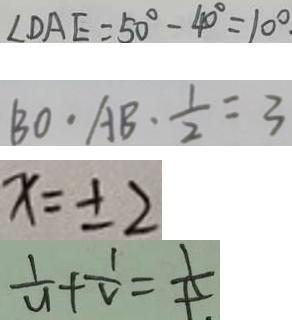<formula> <loc_0><loc_0><loc_500><loc_500>\angle D A E = 5 0 ^ { \circ } - 4 0 ^ { \circ } = 1 0 ^ { \circ } 
 B O \cdot A B \cdot \frac { 1 } { 2 } = 3 
 x = \pm 2 
 \frac { 1 } { u } + \frac { 1 } { v } = \frac { 1 } { t }</formula> 